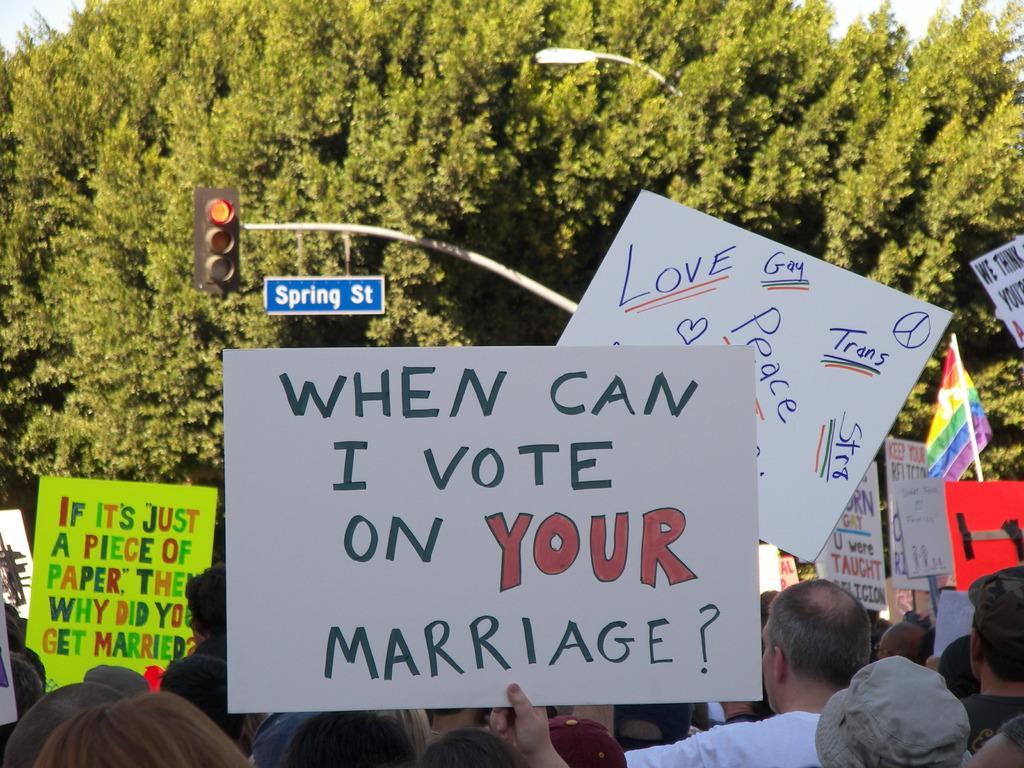Who or what is present in the image? There are people in the image. What are the people holding in the image? The people are holding banners. What can be read on the banners? The banners have text on them. What can be seen in the background of the image? There is a signal pole and trees in the background of the image. What type of toe is visible on the banner in the image? There are no toes present on the banners or in the image. What material is the brass flock made of in the image? There is no mention of a brass flock in the image or the provided facts. 